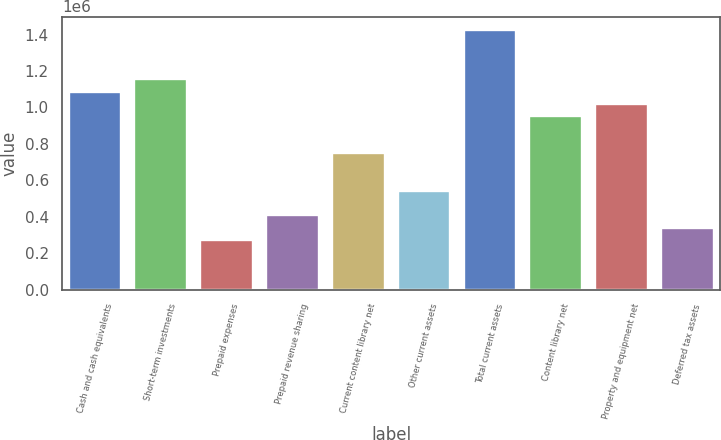Convert chart. <chart><loc_0><loc_0><loc_500><loc_500><bar_chart><fcel>Cash and cash equivalents<fcel>Short-term investments<fcel>Prepaid expenses<fcel>Prepaid revenue sharing<fcel>Current content library net<fcel>Other current assets<fcel>Total current assets<fcel>Content library net<fcel>Property and equipment net<fcel>Deferred tax assets<nl><fcel>1.08754e+06<fcel>1.15551e+06<fcel>271925<fcel>407862<fcel>747702<fcel>543798<fcel>1.42738e+06<fcel>951606<fcel>1.01957e+06<fcel>339894<nl></chart> 